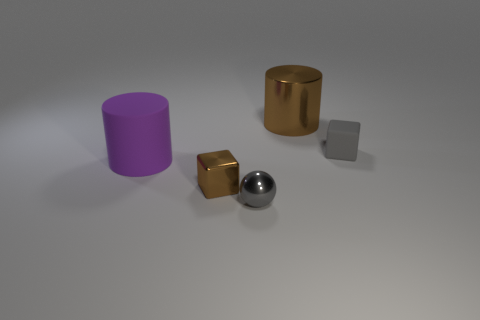Add 3 small gray metallic balls. How many objects exist? 8 Subtract all cubes. How many objects are left? 3 Subtract all cyan cubes. Subtract all large things. How many objects are left? 3 Add 4 rubber objects. How many rubber objects are left? 6 Add 1 tiny gray metal objects. How many tiny gray metal objects exist? 2 Subtract 0 red balls. How many objects are left? 5 